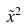Convert formula to latex. <formula><loc_0><loc_0><loc_500><loc_500>\tilde { x } ^ { 2 }</formula> 